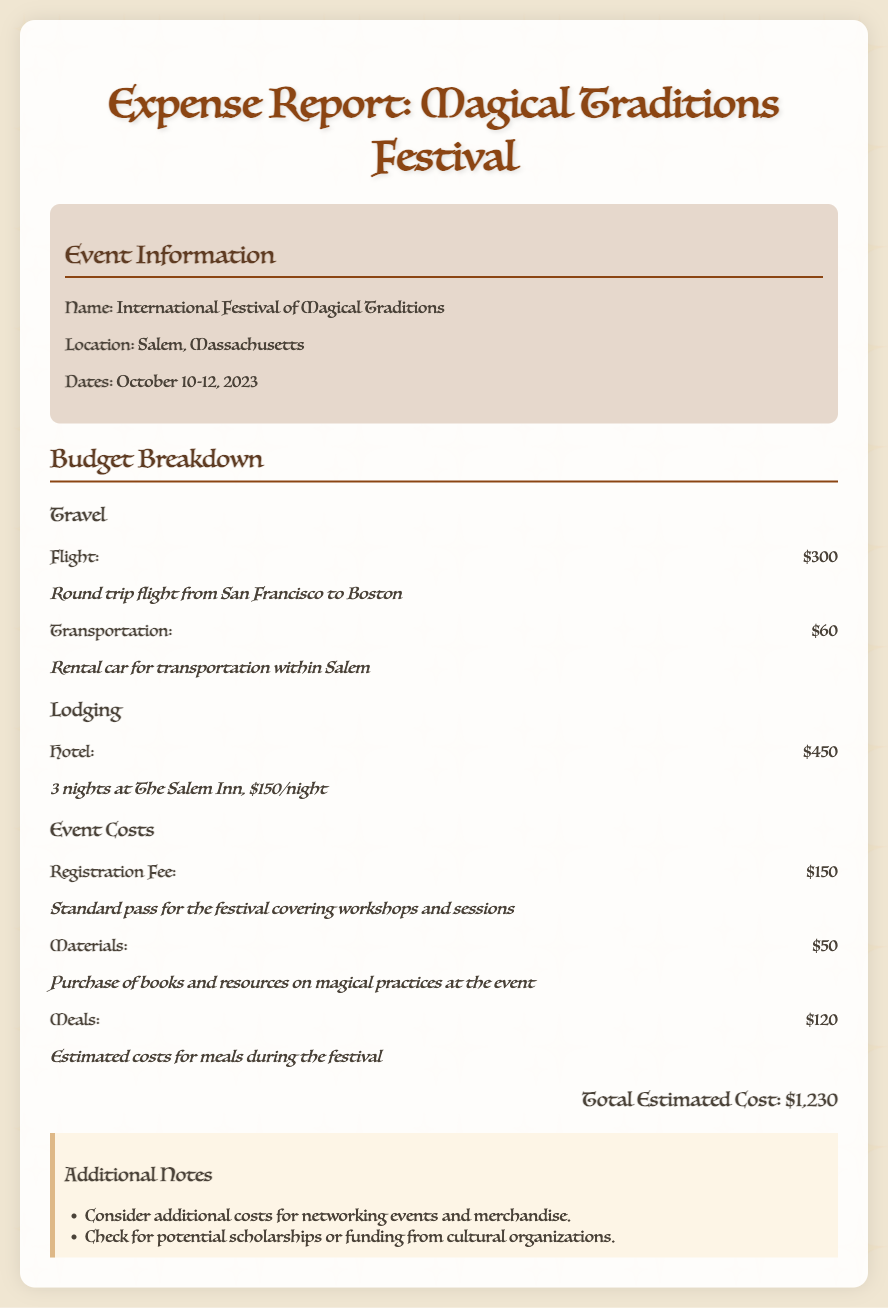What is the name of the event? The document specifies the name of the event as "International Festival of Magical Traditions."
Answer: International Festival of Magical Traditions Where is the festival located? The document provides the location as "Salem, Massachusetts."
Answer: Salem, Massachusetts What are the dates of the festival? The festival dates are detailed in the document as October 10-12, 2023.
Answer: October 10-12, 2023 What is the total estimated cost? The total estimated cost is calculated and presented as $1,230 in the document.
Answer: $1,230 How much is the flight cost? The document mentions the flight cost as $300.
Answer: $300 What is the lodging cost for 3 nights? The document lists the hotel cost as $450 for three nights at the Salem Inn.
Answer: $450 What is the registration fee for the festival? The registration fee is noted in the document as $150.
Answer: $150 What is the estimated cost for meals? The document indicates that the estimated cost for meals is $120.
Answer: $120 What type of transportation is mentioned in the budget? The budget includes a rental car for transportation within Salem.
Answer: Rental car 